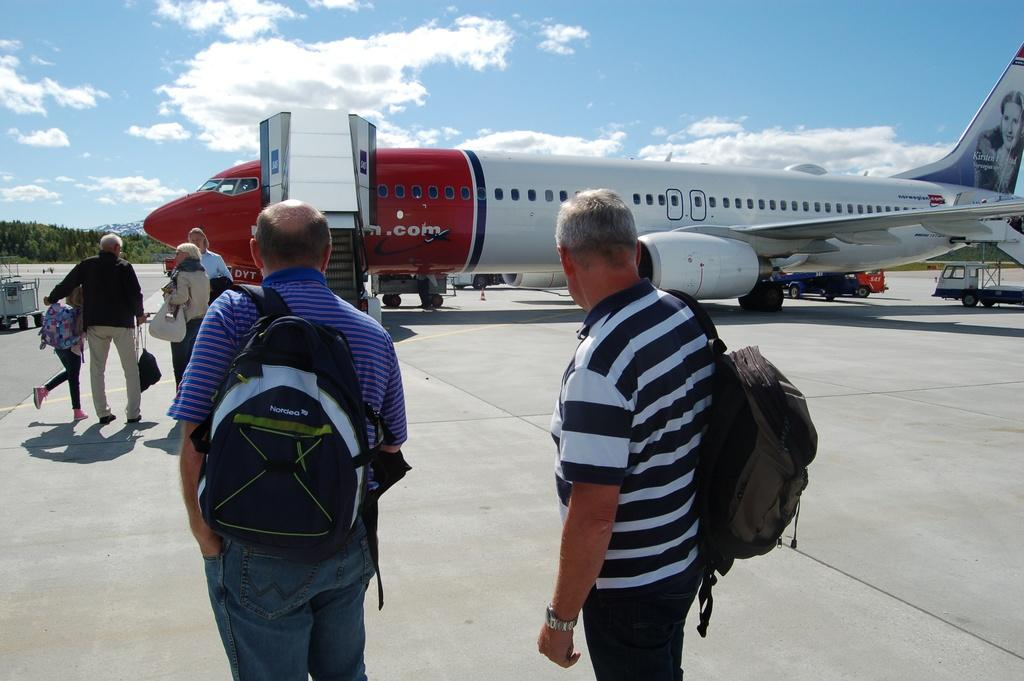<image>
Present a compact description of the photo's key features. people getting ready to board a red and white norwegian airplane 